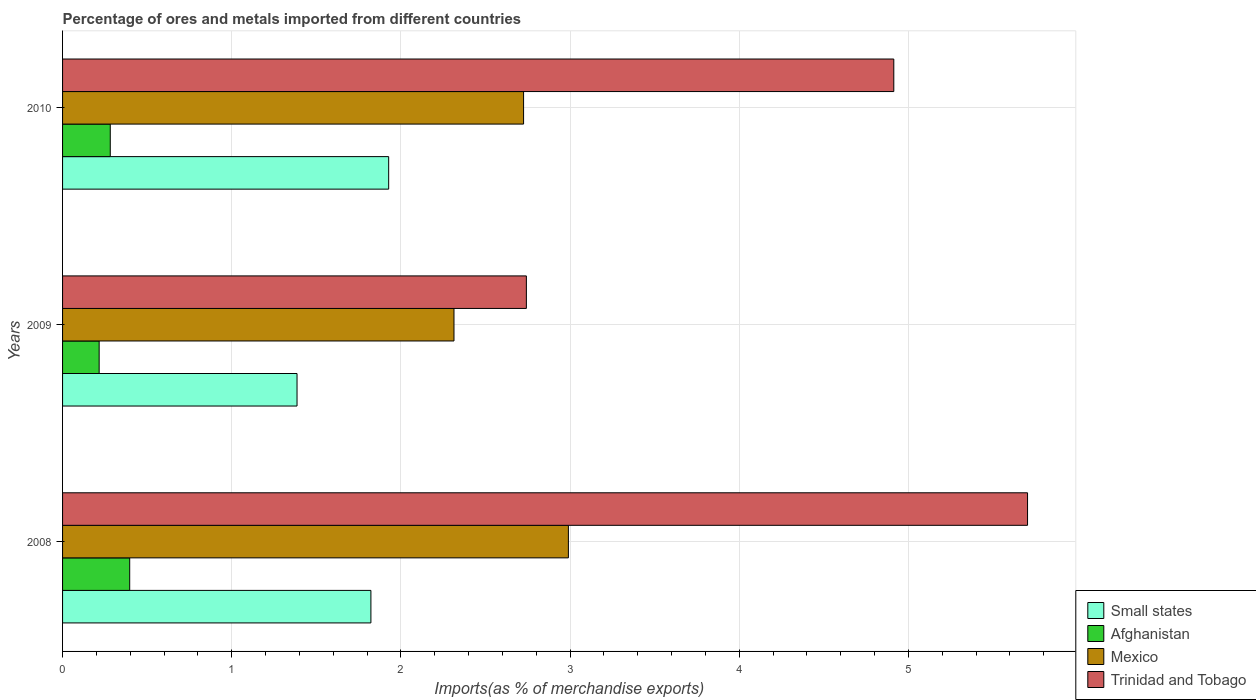How many groups of bars are there?
Keep it short and to the point. 3. In how many cases, is the number of bars for a given year not equal to the number of legend labels?
Offer a very short reply. 0. What is the percentage of imports to different countries in Mexico in 2010?
Offer a very short reply. 2.72. Across all years, what is the maximum percentage of imports to different countries in Afghanistan?
Give a very brief answer. 0.4. Across all years, what is the minimum percentage of imports to different countries in Small states?
Make the answer very short. 1.39. In which year was the percentage of imports to different countries in Trinidad and Tobago maximum?
Offer a terse response. 2008. In which year was the percentage of imports to different countries in Trinidad and Tobago minimum?
Keep it short and to the point. 2009. What is the total percentage of imports to different countries in Trinidad and Tobago in the graph?
Your response must be concise. 13.36. What is the difference between the percentage of imports to different countries in Afghanistan in 2008 and that in 2010?
Your answer should be very brief. 0.11. What is the difference between the percentage of imports to different countries in Small states in 2010 and the percentage of imports to different countries in Mexico in 2009?
Keep it short and to the point. -0.39. What is the average percentage of imports to different countries in Afghanistan per year?
Your answer should be very brief. 0.3. In the year 2008, what is the difference between the percentage of imports to different countries in Small states and percentage of imports to different countries in Trinidad and Tobago?
Your response must be concise. -3.88. In how many years, is the percentage of imports to different countries in Small states greater than 3.2 %?
Your answer should be compact. 0. What is the ratio of the percentage of imports to different countries in Mexico in 2009 to that in 2010?
Your answer should be very brief. 0.85. Is the percentage of imports to different countries in Afghanistan in 2008 less than that in 2010?
Keep it short and to the point. No. What is the difference between the highest and the second highest percentage of imports to different countries in Small states?
Ensure brevity in your answer.  0.11. What is the difference between the highest and the lowest percentage of imports to different countries in Small states?
Your answer should be very brief. 0.54. What does the 3rd bar from the top in 2010 represents?
Ensure brevity in your answer.  Afghanistan. What does the 1st bar from the bottom in 2010 represents?
Keep it short and to the point. Small states. Is it the case that in every year, the sum of the percentage of imports to different countries in Trinidad and Tobago and percentage of imports to different countries in Small states is greater than the percentage of imports to different countries in Mexico?
Keep it short and to the point. Yes. How many bars are there?
Your answer should be compact. 12. Does the graph contain grids?
Ensure brevity in your answer.  Yes. Where does the legend appear in the graph?
Offer a terse response. Bottom right. What is the title of the graph?
Keep it short and to the point. Percentage of ores and metals imported from different countries. What is the label or title of the X-axis?
Give a very brief answer. Imports(as % of merchandise exports). What is the Imports(as % of merchandise exports) in Small states in 2008?
Your response must be concise. 1.82. What is the Imports(as % of merchandise exports) in Afghanistan in 2008?
Offer a very short reply. 0.4. What is the Imports(as % of merchandise exports) in Mexico in 2008?
Your response must be concise. 2.99. What is the Imports(as % of merchandise exports) in Trinidad and Tobago in 2008?
Your response must be concise. 5.7. What is the Imports(as % of merchandise exports) in Small states in 2009?
Your answer should be compact. 1.39. What is the Imports(as % of merchandise exports) in Afghanistan in 2009?
Offer a very short reply. 0.22. What is the Imports(as % of merchandise exports) in Mexico in 2009?
Your response must be concise. 2.31. What is the Imports(as % of merchandise exports) of Trinidad and Tobago in 2009?
Keep it short and to the point. 2.74. What is the Imports(as % of merchandise exports) in Small states in 2010?
Offer a terse response. 1.93. What is the Imports(as % of merchandise exports) of Afghanistan in 2010?
Keep it short and to the point. 0.28. What is the Imports(as % of merchandise exports) in Mexico in 2010?
Your answer should be compact. 2.72. What is the Imports(as % of merchandise exports) of Trinidad and Tobago in 2010?
Your response must be concise. 4.91. Across all years, what is the maximum Imports(as % of merchandise exports) of Small states?
Keep it short and to the point. 1.93. Across all years, what is the maximum Imports(as % of merchandise exports) of Afghanistan?
Keep it short and to the point. 0.4. Across all years, what is the maximum Imports(as % of merchandise exports) of Mexico?
Your response must be concise. 2.99. Across all years, what is the maximum Imports(as % of merchandise exports) of Trinidad and Tobago?
Offer a very short reply. 5.7. Across all years, what is the minimum Imports(as % of merchandise exports) of Small states?
Your answer should be compact. 1.39. Across all years, what is the minimum Imports(as % of merchandise exports) in Afghanistan?
Give a very brief answer. 0.22. Across all years, what is the minimum Imports(as % of merchandise exports) of Mexico?
Ensure brevity in your answer.  2.31. Across all years, what is the minimum Imports(as % of merchandise exports) in Trinidad and Tobago?
Keep it short and to the point. 2.74. What is the total Imports(as % of merchandise exports) in Small states in the graph?
Your response must be concise. 5.14. What is the total Imports(as % of merchandise exports) in Afghanistan in the graph?
Your response must be concise. 0.9. What is the total Imports(as % of merchandise exports) in Mexico in the graph?
Your answer should be compact. 8.03. What is the total Imports(as % of merchandise exports) of Trinidad and Tobago in the graph?
Provide a succinct answer. 13.36. What is the difference between the Imports(as % of merchandise exports) of Small states in 2008 and that in 2009?
Your response must be concise. 0.44. What is the difference between the Imports(as % of merchandise exports) of Afghanistan in 2008 and that in 2009?
Ensure brevity in your answer.  0.18. What is the difference between the Imports(as % of merchandise exports) of Mexico in 2008 and that in 2009?
Give a very brief answer. 0.68. What is the difference between the Imports(as % of merchandise exports) of Trinidad and Tobago in 2008 and that in 2009?
Offer a very short reply. 2.96. What is the difference between the Imports(as % of merchandise exports) of Small states in 2008 and that in 2010?
Provide a succinct answer. -0.11. What is the difference between the Imports(as % of merchandise exports) in Afghanistan in 2008 and that in 2010?
Provide a succinct answer. 0.11. What is the difference between the Imports(as % of merchandise exports) in Mexico in 2008 and that in 2010?
Offer a terse response. 0.27. What is the difference between the Imports(as % of merchandise exports) of Trinidad and Tobago in 2008 and that in 2010?
Provide a short and direct response. 0.79. What is the difference between the Imports(as % of merchandise exports) of Small states in 2009 and that in 2010?
Your answer should be very brief. -0.54. What is the difference between the Imports(as % of merchandise exports) of Afghanistan in 2009 and that in 2010?
Give a very brief answer. -0.07. What is the difference between the Imports(as % of merchandise exports) in Mexico in 2009 and that in 2010?
Give a very brief answer. -0.41. What is the difference between the Imports(as % of merchandise exports) in Trinidad and Tobago in 2009 and that in 2010?
Provide a short and direct response. -2.17. What is the difference between the Imports(as % of merchandise exports) in Small states in 2008 and the Imports(as % of merchandise exports) in Afghanistan in 2009?
Your answer should be compact. 1.61. What is the difference between the Imports(as % of merchandise exports) of Small states in 2008 and the Imports(as % of merchandise exports) of Mexico in 2009?
Ensure brevity in your answer.  -0.49. What is the difference between the Imports(as % of merchandise exports) in Small states in 2008 and the Imports(as % of merchandise exports) in Trinidad and Tobago in 2009?
Give a very brief answer. -0.92. What is the difference between the Imports(as % of merchandise exports) in Afghanistan in 2008 and the Imports(as % of merchandise exports) in Mexico in 2009?
Ensure brevity in your answer.  -1.92. What is the difference between the Imports(as % of merchandise exports) of Afghanistan in 2008 and the Imports(as % of merchandise exports) of Trinidad and Tobago in 2009?
Keep it short and to the point. -2.34. What is the difference between the Imports(as % of merchandise exports) of Mexico in 2008 and the Imports(as % of merchandise exports) of Trinidad and Tobago in 2009?
Your response must be concise. 0.25. What is the difference between the Imports(as % of merchandise exports) of Small states in 2008 and the Imports(as % of merchandise exports) of Afghanistan in 2010?
Provide a short and direct response. 1.54. What is the difference between the Imports(as % of merchandise exports) of Small states in 2008 and the Imports(as % of merchandise exports) of Mexico in 2010?
Your answer should be compact. -0.9. What is the difference between the Imports(as % of merchandise exports) in Small states in 2008 and the Imports(as % of merchandise exports) in Trinidad and Tobago in 2010?
Keep it short and to the point. -3.09. What is the difference between the Imports(as % of merchandise exports) of Afghanistan in 2008 and the Imports(as % of merchandise exports) of Mexico in 2010?
Your answer should be compact. -2.33. What is the difference between the Imports(as % of merchandise exports) of Afghanistan in 2008 and the Imports(as % of merchandise exports) of Trinidad and Tobago in 2010?
Give a very brief answer. -4.52. What is the difference between the Imports(as % of merchandise exports) in Mexico in 2008 and the Imports(as % of merchandise exports) in Trinidad and Tobago in 2010?
Keep it short and to the point. -1.92. What is the difference between the Imports(as % of merchandise exports) of Small states in 2009 and the Imports(as % of merchandise exports) of Afghanistan in 2010?
Keep it short and to the point. 1.1. What is the difference between the Imports(as % of merchandise exports) in Small states in 2009 and the Imports(as % of merchandise exports) in Mexico in 2010?
Your answer should be compact. -1.34. What is the difference between the Imports(as % of merchandise exports) of Small states in 2009 and the Imports(as % of merchandise exports) of Trinidad and Tobago in 2010?
Make the answer very short. -3.53. What is the difference between the Imports(as % of merchandise exports) in Afghanistan in 2009 and the Imports(as % of merchandise exports) in Mexico in 2010?
Your answer should be compact. -2.51. What is the difference between the Imports(as % of merchandise exports) in Afghanistan in 2009 and the Imports(as % of merchandise exports) in Trinidad and Tobago in 2010?
Make the answer very short. -4.7. What is the difference between the Imports(as % of merchandise exports) in Mexico in 2009 and the Imports(as % of merchandise exports) in Trinidad and Tobago in 2010?
Your answer should be very brief. -2.6. What is the average Imports(as % of merchandise exports) of Small states per year?
Offer a terse response. 1.71. What is the average Imports(as % of merchandise exports) of Afghanistan per year?
Your answer should be very brief. 0.3. What is the average Imports(as % of merchandise exports) of Mexico per year?
Offer a very short reply. 2.68. What is the average Imports(as % of merchandise exports) in Trinidad and Tobago per year?
Offer a very short reply. 4.45. In the year 2008, what is the difference between the Imports(as % of merchandise exports) of Small states and Imports(as % of merchandise exports) of Afghanistan?
Provide a succinct answer. 1.43. In the year 2008, what is the difference between the Imports(as % of merchandise exports) of Small states and Imports(as % of merchandise exports) of Mexico?
Make the answer very short. -1.17. In the year 2008, what is the difference between the Imports(as % of merchandise exports) of Small states and Imports(as % of merchandise exports) of Trinidad and Tobago?
Provide a succinct answer. -3.88. In the year 2008, what is the difference between the Imports(as % of merchandise exports) in Afghanistan and Imports(as % of merchandise exports) in Mexico?
Offer a terse response. -2.59. In the year 2008, what is the difference between the Imports(as % of merchandise exports) of Afghanistan and Imports(as % of merchandise exports) of Trinidad and Tobago?
Ensure brevity in your answer.  -5.31. In the year 2008, what is the difference between the Imports(as % of merchandise exports) in Mexico and Imports(as % of merchandise exports) in Trinidad and Tobago?
Your answer should be compact. -2.71. In the year 2009, what is the difference between the Imports(as % of merchandise exports) of Small states and Imports(as % of merchandise exports) of Afghanistan?
Provide a short and direct response. 1.17. In the year 2009, what is the difference between the Imports(as % of merchandise exports) of Small states and Imports(as % of merchandise exports) of Mexico?
Offer a very short reply. -0.93. In the year 2009, what is the difference between the Imports(as % of merchandise exports) in Small states and Imports(as % of merchandise exports) in Trinidad and Tobago?
Make the answer very short. -1.36. In the year 2009, what is the difference between the Imports(as % of merchandise exports) of Afghanistan and Imports(as % of merchandise exports) of Mexico?
Ensure brevity in your answer.  -2.1. In the year 2009, what is the difference between the Imports(as % of merchandise exports) in Afghanistan and Imports(as % of merchandise exports) in Trinidad and Tobago?
Your answer should be very brief. -2.53. In the year 2009, what is the difference between the Imports(as % of merchandise exports) of Mexico and Imports(as % of merchandise exports) of Trinidad and Tobago?
Ensure brevity in your answer.  -0.43. In the year 2010, what is the difference between the Imports(as % of merchandise exports) of Small states and Imports(as % of merchandise exports) of Afghanistan?
Provide a short and direct response. 1.65. In the year 2010, what is the difference between the Imports(as % of merchandise exports) in Small states and Imports(as % of merchandise exports) in Mexico?
Provide a short and direct response. -0.8. In the year 2010, what is the difference between the Imports(as % of merchandise exports) in Small states and Imports(as % of merchandise exports) in Trinidad and Tobago?
Provide a succinct answer. -2.99. In the year 2010, what is the difference between the Imports(as % of merchandise exports) in Afghanistan and Imports(as % of merchandise exports) in Mexico?
Offer a very short reply. -2.44. In the year 2010, what is the difference between the Imports(as % of merchandise exports) of Afghanistan and Imports(as % of merchandise exports) of Trinidad and Tobago?
Provide a short and direct response. -4.63. In the year 2010, what is the difference between the Imports(as % of merchandise exports) of Mexico and Imports(as % of merchandise exports) of Trinidad and Tobago?
Keep it short and to the point. -2.19. What is the ratio of the Imports(as % of merchandise exports) of Small states in 2008 to that in 2009?
Offer a terse response. 1.31. What is the ratio of the Imports(as % of merchandise exports) of Afghanistan in 2008 to that in 2009?
Your answer should be very brief. 1.83. What is the ratio of the Imports(as % of merchandise exports) of Mexico in 2008 to that in 2009?
Give a very brief answer. 1.29. What is the ratio of the Imports(as % of merchandise exports) of Trinidad and Tobago in 2008 to that in 2009?
Your answer should be very brief. 2.08. What is the ratio of the Imports(as % of merchandise exports) in Small states in 2008 to that in 2010?
Your response must be concise. 0.95. What is the ratio of the Imports(as % of merchandise exports) of Afghanistan in 2008 to that in 2010?
Keep it short and to the point. 1.41. What is the ratio of the Imports(as % of merchandise exports) of Mexico in 2008 to that in 2010?
Ensure brevity in your answer.  1.1. What is the ratio of the Imports(as % of merchandise exports) in Trinidad and Tobago in 2008 to that in 2010?
Your answer should be compact. 1.16. What is the ratio of the Imports(as % of merchandise exports) of Small states in 2009 to that in 2010?
Offer a very short reply. 0.72. What is the ratio of the Imports(as % of merchandise exports) in Afghanistan in 2009 to that in 2010?
Your answer should be very brief. 0.77. What is the ratio of the Imports(as % of merchandise exports) in Mexico in 2009 to that in 2010?
Offer a very short reply. 0.85. What is the ratio of the Imports(as % of merchandise exports) of Trinidad and Tobago in 2009 to that in 2010?
Your answer should be compact. 0.56. What is the difference between the highest and the second highest Imports(as % of merchandise exports) of Small states?
Keep it short and to the point. 0.11. What is the difference between the highest and the second highest Imports(as % of merchandise exports) in Afghanistan?
Your answer should be very brief. 0.11. What is the difference between the highest and the second highest Imports(as % of merchandise exports) in Mexico?
Give a very brief answer. 0.27. What is the difference between the highest and the second highest Imports(as % of merchandise exports) of Trinidad and Tobago?
Provide a succinct answer. 0.79. What is the difference between the highest and the lowest Imports(as % of merchandise exports) of Small states?
Your answer should be very brief. 0.54. What is the difference between the highest and the lowest Imports(as % of merchandise exports) of Afghanistan?
Give a very brief answer. 0.18. What is the difference between the highest and the lowest Imports(as % of merchandise exports) in Mexico?
Ensure brevity in your answer.  0.68. What is the difference between the highest and the lowest Imports(as % of merchandise exports) in Trinidad and Tobago?
Your response must be concise. 2.96. 